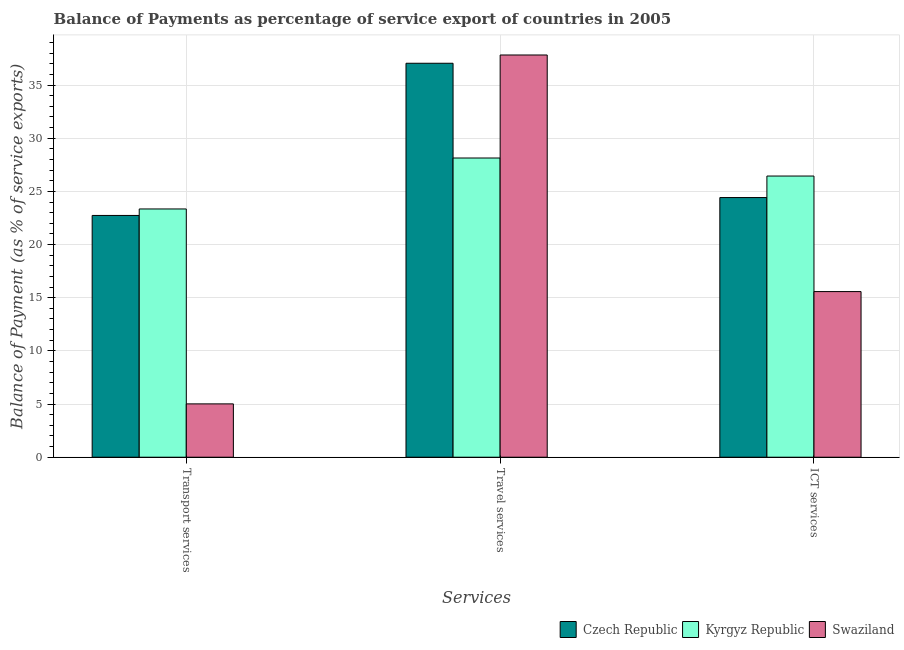How many groups of bars are there?
Ensure brevity in your answer.  3. Are the number of bars per tick equal to the number of legend labels?
Provide a succinct answer. Yes. How many bars are there on the 3rd tick from the left?
Your answer should be compact. 3. What is the label of the 1st group of bars from the left?
Your answer should be very brief. Transport services. What is the balance of payment of transport services in Czech Republic?
Provide a short and direct response. 22.74. Across all countries, what is the maximum balance of payment of transport services?
Your answer should be very brief. 23.35. Across all countries, what is the minimum balance of payment of travel services?
Make the answer very short. 28.14. In which country was the balance of payment of travel services maximum?
Your response must be concise. Swaziland. In which country was the balance of payment of transport services minimum?
Keep it short and to the point. Swaziland. What is the total balance of payment of travel services in the graph?
Your response must be concise. 103.03. What is the difference between the balance of payment of transport services in Swaziland and that in Kyrgyz Republic?
Offer a very short reply. -18.33. What is the difference between the balance of payment of ict services in Czech Republic and the balance of payment of travel services in Swaziland?
Offer a terse response. -13.41. What is the average balance of payment of travel services per country?
Give a very brief answer. 34.34. What is the difference between the balance of payment of travel services and balance of payment of ict services in Czech Republic?
Offer a terse response. 12.63. In how many countries, is the balance of payment of travel services greater than 9 %?
Give a very brief answer. 3. What is the ratio of the balance of payment of travel services in Czech Republic to that in Swaziland?
Ensure brevity in your answer.  0.98. Is the balance of payment of ict services in Kyrgyz Republic less than that in Czech Republic?
Your answer should be very brief. No. What is the difference between the highest and the second highest balance of payment of transport services?
Your answer should be compact. 0.61. What is the difference between the highest and the lowest balance of payment of travel services?
Your answer should be compact. 9.69. Is the sum of the balance of payment of ict services in Czech Republic and Swaziland greater than the maximum balance of payment of transport services across all countries?
Offer a very short reply. Yes. What does the 2nd bar from the left in ICT services represents?
Give a very brief answer. Kyrgyz Republic. What does the 3rd bar from the right in ICT services represents?
Provide a short and direct response. Czech Republic. How many countries are there in the graph?
Give a very brief answer. 3. Are the values on the major ticks of Y-axis written in scientific E-notation?
Make the answer very short. No. Does the graph contain any zero values?
Your response must be concise. No. Where does the legend appear in the graph?
Offer a very short reply. Bottom right. How many legend labels are there?
Offer a terse response. 3. How are the legend labels stacked?
Provide a short and direct response. Horizontal. What is the title of the graph?
Offer a very short reply. Balance of Payments as percentage of service export of countries in 2005. Does "Brazil" appear as one of the legend labels in the graph?
Provide a succinct answer. No. What is the label or title of the X-axis?
Your response must be concise. Services. What is the label or title of the Y-axis?
Offer a very short reply. Balance of Payment (as % of service exports). What is the Balance of Payment (as % of service exports) of Czech Republic in Transport services?
Offer a very short reply. 22.74. What is the Balance of Payment (as % of service exports) of Kyrgyz Republic in Transport services?
Give a very brief answer. 23.35. What is the Balance of Payment (as % of service exports) in Swaziland in Transport services?
Make the answer very short. 5.02. What is the Balance of Payment (as % of service exports) in Czech Republic in Travel services?
Your answer should be compact. 37.05. What is the Balance of Payment (as % of service exports) in Kyrgyz Republic in Travel services?
Keep it short and to the point. 28.14. What is the Balance of Payment (as % of service exports) of Swaziland in Travel services?
Offer a very short reply. 37.83. What is the Balance of Payment (as % of service exports) of Czech Republic in ICT services?
Ensure brevity in your answer.  24.42. What is the Balance of Payment (as % of service exports) in Kyrgyz Republic in ICT services?
Your answer should be very brief. 26.45. What is the Balance of Payment (as % of service exports) of Swaziland in ICT services?
Give a very brief answer. 15.58. Across all Services, what is the maximum Balance of Payment (as % of service exports) in Czech Republic?
Ensure brevity in your answer.  37.05. Across all Services, what is the maximum Balance of Payment (as % of service exports) of Kyrgyz Republic?
Provide a succinct answer. 28.14. Across all Services, what is the maximum Balance of Payment (as % of service exports) of Swaziland?
Offer a terse response. 37.83. Across all Services, what is the minimum Balance of Payment (as % of service exports) of Czech Republic?
Give a very brief answer. 22.74. Across all Services, what is the minimum Balance of Payment (as % of service exports) in Kyrgyz Republic?
Your answer should be very brief. 23.35. Across all Services, what is the minimum Balance of Payment (as % of service exports) in Swaziland?
Your answer should be very brief. 5.02. What is the total Balance of Payment (as % of service exports) in Czech Republic in the graph?
Provide a short and direct response. 84.22. What is the total Balance of Payment (as % of service exports) of Kyrgyz Republic in the graph?
Keep it short and to the point. 77.94. What is the total Balance of Payment (as % of service exports) of Swaziland in the graph?
Keep it short and to the point. 58.43. What is the difference between the Balance of Payment (as % of service exports) in Czech Republic in Transport services and that in Travel services?
Provide a short and direct response. -14.31. What is the difference between the Balance of Payment (as % of service exports) of Kyrgyz Republic in Transport services and that in Travel services?
Keep it short and to the point. -4.79. What is the difference between the Balance of Payment (as % of service exports) of Swaziland in Transport services and that in Travel services?
Give a very brief answer. -32.81. What is the difference between the Balance of Payment (as % of service exports) in Czech Republic in Transport services and that in ICT services?
Provide a succinct answer. -1.68. What is the difference between the Balance of Payment (as % of service exports) in Kyrgyz Republic in Transport services and that in ICT services?
Ensure brevity in your answer.  -3.1. What is the difference between the Balance of Payment (as % of service exports) of Swaziland in Transport services and that in ICT services?
Your answer should be very brief. -10.56. What is the difference between the Balance of Payment (as % of service exports) of Czech Republic in Travel services and that in ICT services?
Your answer should be very brief. 12.63. What is the difference between the Balance of Payment (as % of service exports) in Kyrgyz Republic in Travel services and that in ICT services?
Offer a very short reply. 1.7. What is the difference between the Balance of Payment (as % of service exports) in Swaziland in Travel services and that in ICT services?
Your answer should be compact. 22.25. What is the difference between the Balance of Payment (as % of service exports) of Czech Republic in Transport services and the Balance of Payment (as % of service exports) of Kyrgyz Republic in Travel services?
Keep it short and to the point. -5.4. What is the difference between the Balance of Payment (as % of service exports) of Czech Republic in Transport services and the Balance of Payment (as % of service exports) of Swaziland in Travel services?
Keep it short and to the point. -15.09. What is the difference between the Balance of Payment (as % of service exports) of Kyrgyz Republic in Transport services and the Balance of Payment (as % of service exports) of Swaziland in Travel services?
Your answer should be compact. -14.48. What is the difference between the Balance of Payment (as % of service exports) in Czech Republic in Transport services and the Balance of Payment (as % of service exports) in Kyrgyz Republic in ICT services?
Make the answer very short. -3.71. What is the difference between the Balance of Payment (as % of service exports) of Czech Republic in Transport services and the Balance of Payment (as % of service exports) of Swaziland in ICT services?
Your response must be concise. 7.16. What is the difference between the Balance of Payment (as % of service exports) in Kyrgyz Republic in Transport services and the Balance of Payment (as % of service exports) in Swaziland in ICT services?
Offer a terse response. 7.77. What is the difference between the Balance of Payment (as % of service exports) in Czech Republic in Travel services and the Balance of Payment (as % of service exports) in Kyrgyz Republic in ICT services?
Your response must be concise. 10.61. What is the difference between the Balance of Payment (as % of service exports) in Czech Republic in Travel services and the Balance of Payment (as % of service exports) in Swaziland in ICT services?
Offer a terse response. 21.48. What is the difference between the Balance of Payment (as % of service exports) in Kyrgyz Republic in Travel services and the Balance of Payment (as % of service exports) in Swaziland in ICT services?
Keep it short and to the point. 12.56. What is the average Balance of Payment (as % of service exports) in Czech Republic per Services?
Your answer should be very brief. 28.07. What is the average Balance of Payment (as % of service exports) of Kyrgyz Republic per Services?
Your answer should be very brief. 25.98. What is the average Balance of Payment (as % of service exports) of Swaziland per Services?
Your response must be concise. 19.48. What is the difference between the Balance of Payment (as % of service exports) in Czech Republic and Balance of Payment (as % of service exports) in Kyrgyz Republic in Transport services?
Ensure brevity in your answer.  -0.61. What is the difference between the Balance of Payment (as % of service exports) of Czech Republic and Balance of Payment (as % of service exports) of Swaziland in Transport services?
Your response must be concise. 17.72. What is the difference between the Balance of Payment (as % of service exports) of Kyrgyz Republic and Balance of Payment (as % of service exports) of Swaziland in Transport services?
Provide a succinct answer. 18.33. What is the difference between the Balance of Payment (as % of service exports) of Czech Republic and Balance of Payment (as % of service exports) of Kyrgyz Republic in Travel services?
Keep it short and to the point. 8.91. What is the difference between the Balance of Payment (as % of service exports) in Czech Republic and Balance of Payment (as % of service exports) in Swaziland in Travel services?
Keep it short and to the point. -0.78. What is the difference between the Balance of Payment (as % of service exports) of Kyrgyz Republic and Balance of Payment (as % of service exports) of Swaziland in Travel services?
Offer a very short reply. -9.69. What is the difference between the Balance of Payment (as % of service exports) of Czech Republic and Balance of Payment (as % of service exports) of Kyrgyz Republic in ICT services?
Keep it short and to the point. -2.02. What is the difference between the Balance of Payment (as % of service exports) of Czech Republic and Balance of Payment (as % of service exports) of Swaziland in ICT services?
Provide a succinct answer. 8.84. What is the difference between the Balance of Payment (as % of service exports) of Kyrgyz Republic and Balance of Payment (as % of service exports) of Swaziland in ICT services?
Offer a very short reply. 10.87. What is the ratio of the Balance of Payment (as % of service exports) of Czech Republic in Transport services to that in Travel services?
Offer a terse response. 0.61. What is the ratio of the Balance of Payment (as % of service exports) in Kyrgyz Republic in Transport services to that in Travel services?
Offer a very short reply. 0.83. What is the ratio of the Balance of Payment (as % of service exports) of Swaziland in Transport services to that in Travel services?
Your answer should be very brief. 0.13. What is the ratio of the Balance of Payment (as % of service exports) of Czech Republic in Transport services to that in ICT services?
Give a very brief answer. 0.93. What is the ratio of the Balance of Payment (as % of service exports) in Kyrgyz Republic in Transport services to that in ICT services?
Give a very brief answer. 0.88. What is the ratio of the Balance of Payment (as % of service exports) in Swaziland in Transport services to that in ICT services?
Keep it short and to the point. 0.32. What is the ratio of the Balance of Payment (as % of service exports) in Czech Republic in Travel services to that in ICT services?
Your response must be concise. 1.52. What is the ratio of the Balance of Payment (as % of service exports) in Kyrgyz Republic in Travel services to that in ICT services?
Offer a terse response. 1.06. What is the ratio of the Balance of Payment (as % of service exports) of Swaziland in Travel services to that in ICT services?
Your response must be concise. 2.43. What is the difference between the highest and the second highest Balance of Payment (as % of service exports) in Czech Republic?
Offer a terse response. 12.63. What is the difference between the highest and the second highest Balance of Payment (as % of service exports) in Kyrgyz Republic?
Offer a very short reply. 1.7. What is the difference between the highest and the second highest Balance of Payment (as % of service exports) of Swaziland?
Give a very brief answer. 22.25. What is the difference between the highest and the lowest Balance of Payment (as % of service exports) of Czech Republic?
Your answer should be compact. 14.31. What is the difference between the highest and the lowest Balance of Payment (as % of service exports) in Kyrgyz Republic?
Keep it short and to the point. 4.79. What is the difference between the highest and the lowest Balance of Payment (as % of service exports) of Swaziland?
Keep it short and to the point. 32.81. 